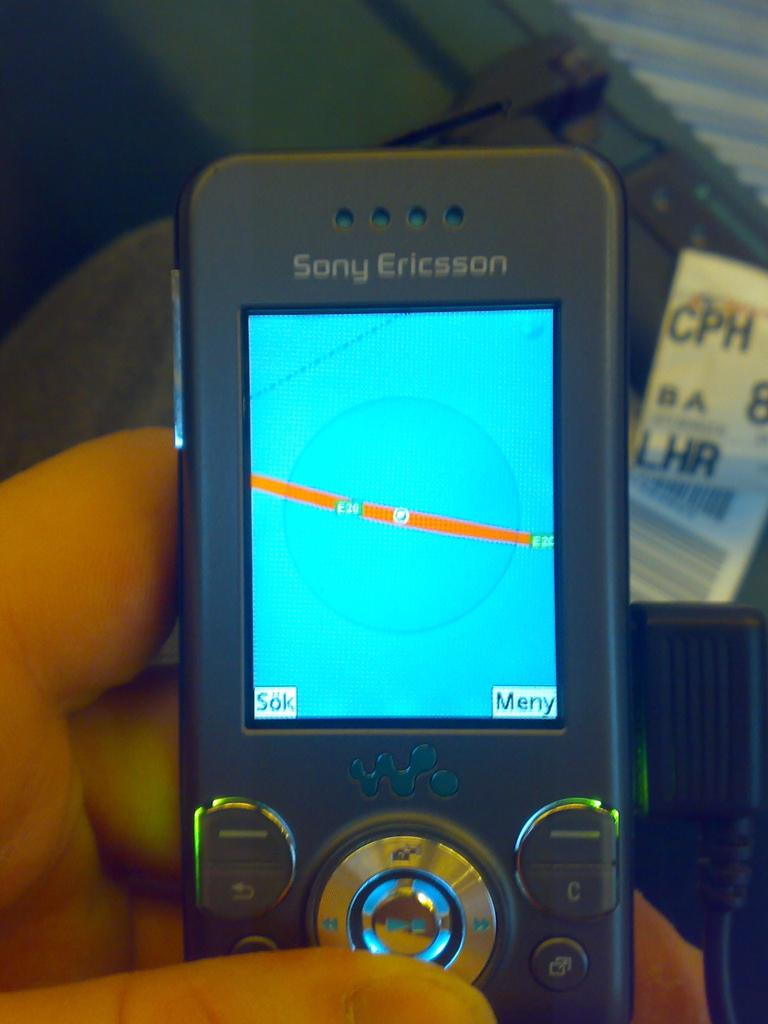<image>
Create a compact narrative representing the image presented. An old Sony Ericsson phone showing navigation screen 